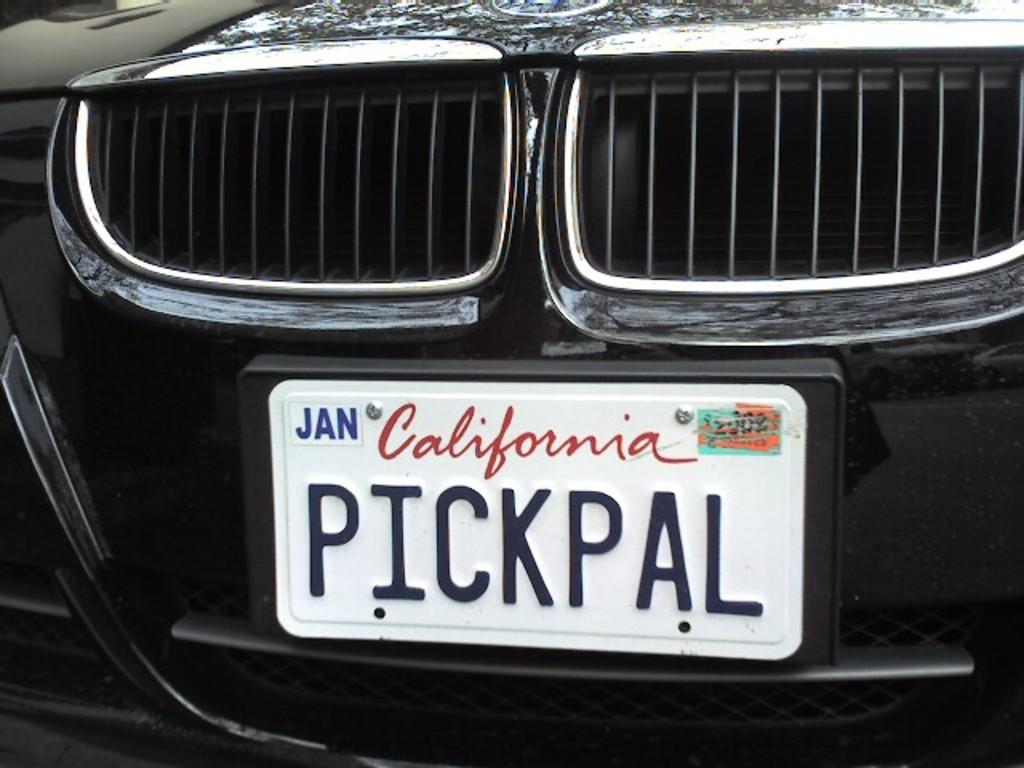Provide a one-sentence caption for the provided image. The California license plate has Pickpal written on it. 